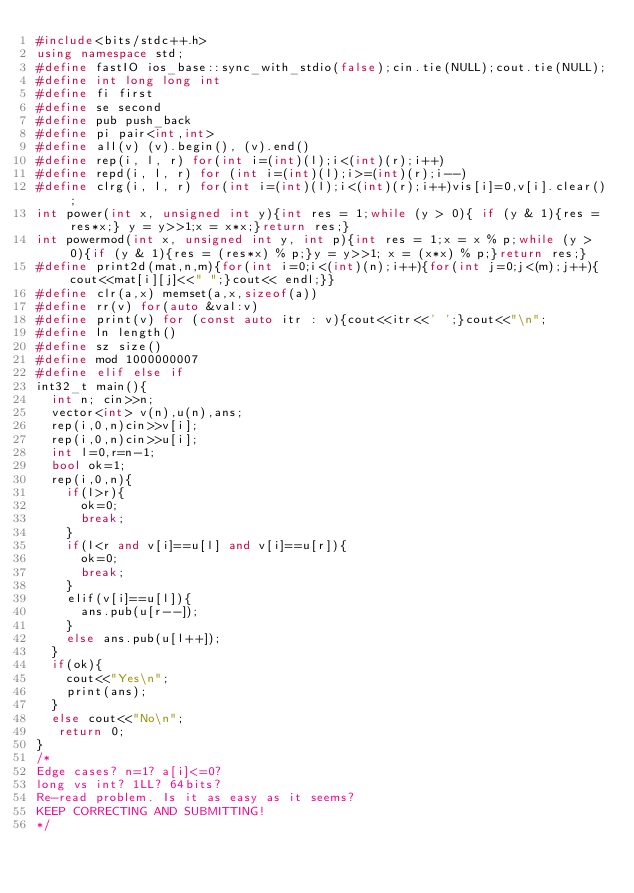Convert code to text. <code><loc_0><loc_0><loc_500><loc_500><_C++_>#include<bits/stdc++.h>
using namespace std;
#define fastIO ios_base::sync_with_stdio(false);cin.tie(NULL);cout.tie(NULL);
#define int long long int
#define fi first
#define se second
#define pub push_back
#define pi pair<int,int>
#define all(v) (v).begin(), (v).end()
#define rep(i, l, r) for(int i=(int)(l);i<(int)(r);i++)
#define repd(i, l, r) for (int i=(int)(l);i>=(int)(r);i--)
#define clrg(i, l, r) for(int i=(int)(l);i<(int)(r);i++)vis[i]=0,v[i].clear();
int power(int x, unsigned int y){int res = 1;while (y > 0){ if (y & 1){res = res*x;} y = y>>1;x = x*x;}return res;}
int powermod(int x, unsigned int y, int p){int res = 1;x = x % p;while (y > 0){if (y & 1){res = (res*x) % p;}y = y>>1; x = (x*x) % p;}return res;}
#define print2d(mat,n,m){for(int i=0;i<(int)(n);i++){for(int j=0;j<(m);j++){cout<<mat[i][j]<<" ";}cout<< endl;}}
#define clr(a,x) memset(a,x,sizeof(a))
#define rr(v) for(auto &val:v)
#define print(v) for (const auto itr : v){cout<<itr<<' ';}cout<<"\n";
#define ln length()
#define sz size()
#define mod 1000000007
#define elif else if
int32_t main(){
  int n; cin>>n;
  vector<int> v(n),u(n),ans;
  rep(i,0,n)cin>>v[i];
  rep(i,0,n)cin>>u[i];
  int l=0,r=n-1;
  bool ok=1;
  rep(i,0,n){
    if(l>r){
      ok=0;
      break;
    }
    if(l<r and v[i]==u[l] and v[i]==u[r]){
      ok=0;
      break;
    }
    elif(v[i]==u[l]){
      ans.pub(u[r--]);
    }
    else ans.pub(u[l++]);
  }
  if(ok){
    cout<<"Yes\n";
    print(ans);
  }
  else cout<<"No\n";
   return 0;
}
/*
Edge cases? n=1? a[i]<=0?
long vs int? 1LL? 64bits?
Re-read problem. Is it as easy as it seems?
KEEP CORRECTING AND SUBMITTING!
*/
</code> 